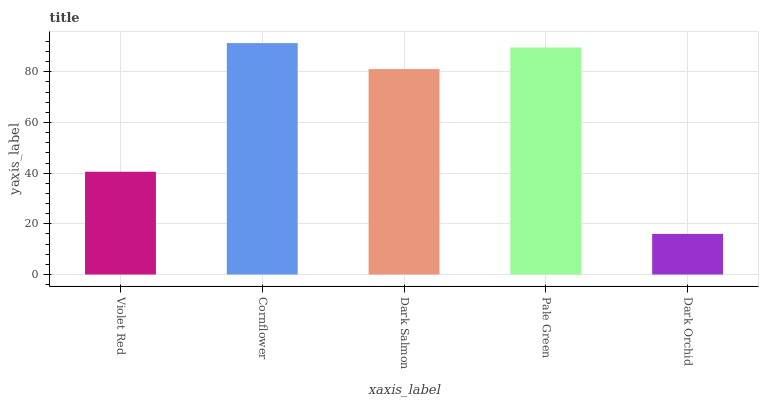Is Dark Orchid the minimum?
Answer yes or no. Yes. Is Cornflower the maximum?
Answer yes or no. Yes. Is Dark Salmon the minimum?
Answer yes or no. No. Is Dark Salmon the maximum?
Answer yes or no. No. Is Cornflower greater than Dark Salmon?
Answer yes or no. Yes. Is Dark Salmon less than Cornflower?
Answer yes or no. Yes. Is Dark Salmon greater than Cornflower?
Answer yes or no. No. Is Cornflower less than Dark Salmon?
Answer yes or no. No. Is Dark Salmon the high median?
Answer yes or no. Yes. Is Dark Salmon the low median?
Answer yes or no. Yes. Is Pale Green the high median?
Answer yes or no. No. Is Violet Red the low median?
Answer yes or no. No. 